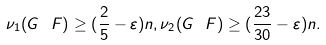<formula> <loc_0><loc_0><loc_500><loc_500>\nu _ { 1 } ( G \ F ) \geq ( \frac { 2 } { 5 } - \varepsilon ) n , \nu _ { 2 } ( G \ F ) \geq ( \frac { 2 3 } { 3 0 } - \varepsilon ) n .</formula> 